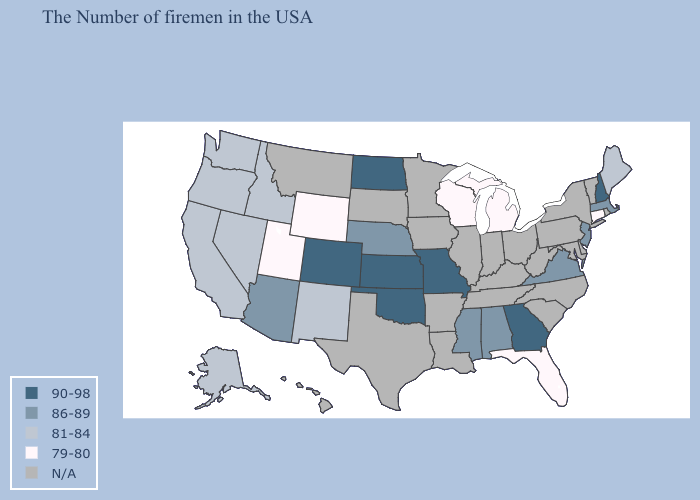What is the value of California?
Give a very brief answer. 81-84. Which states have the highest value in the USA?
Quick response, please. New Hampshire, Georgia, Missouri, Kansas, Oklahoma, North Dakota, Colorado. What is the lowest value in the USA?
Quick response, please. 79-80. What is the lowest value in states that border Connecticut?
Concise answer only. 86-89. Does Oregon have the highest value in the West?
Give a very brief answer. No. What is the value of Maine?
Quick response, please. 81-84. What is the value of Georgia?
Concise answer only. 90-98. Name the states that have a value in the range 81-84?
Short answer required. Maine, New Mexico, Idaho, Nevada, California, Washington, Oregon, Alaska. Which states hav the highest value in the Northeast?
Quick response, please. New Hampshire. What is the value of West Virginia?
Answer briefly. N/A. What is the value of Vermont?
Be succinct. N/A. What is the highest value in states that border Arkansas?
Keep it brief. 90-98. 